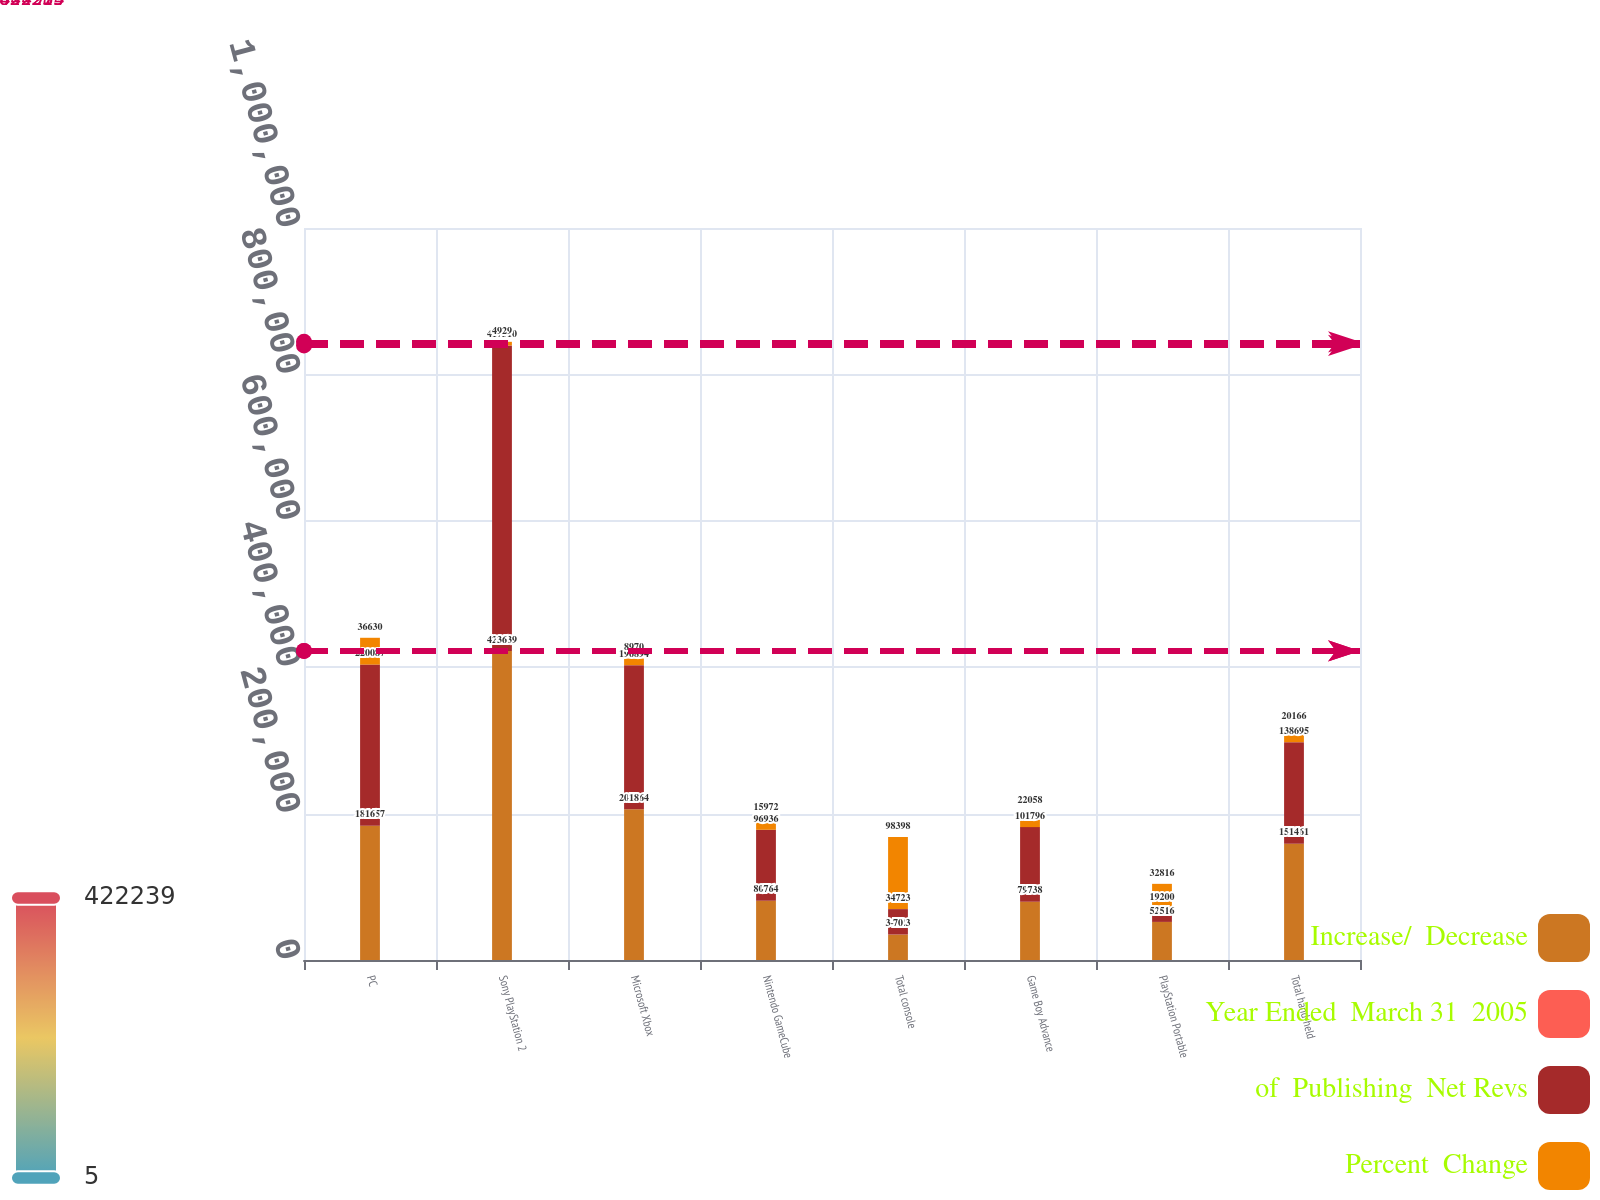<chart> <loc_0><loc_0><loc_500><loc_500><stacked_bar_chart><ecel><fcel>PC<fcel>Sony PlayStation 2<fcel>Microsoft Xbox<fcel>Nintendo GameCube<fcel>Total console<fcel>Game Boy Advance<fcel>PlayStation Portable<fcel>Total hand-held<nl><fcel>Increase/  Decrease<fcel>183457<fcel>422239<fcel>205864<fcel>80964<fcel>34723<fcel>79738<fcel>52016<fcel>158861<nl><fcel>Year Ended  March 31  2005<fcel>16<fcel>36<fcel>18<fcel>7<fcel>70<fcel>7<fcel>5<fcel>14<nl><fcel>of  Publishing  Net Revs<fcel>220087<fcel>417310<fcel>196894<fcel>96936<fcel>34723<fcel>101796<fcel>19200<fcel>138695<nl><fcel>Percent  Change<fcel>36630<fcel>4929<fcel>8970<fcel>15972<fcel>98398<fcel>22058<fcel>32816<fcel>20166<nl></chart> 